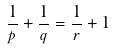<formula> <loc_0><loc_0><loc_500><loc_500>\frac { 1 } { p } + \frac { 1 } { q } = \frac { 1 } { r } + 1</formula> 